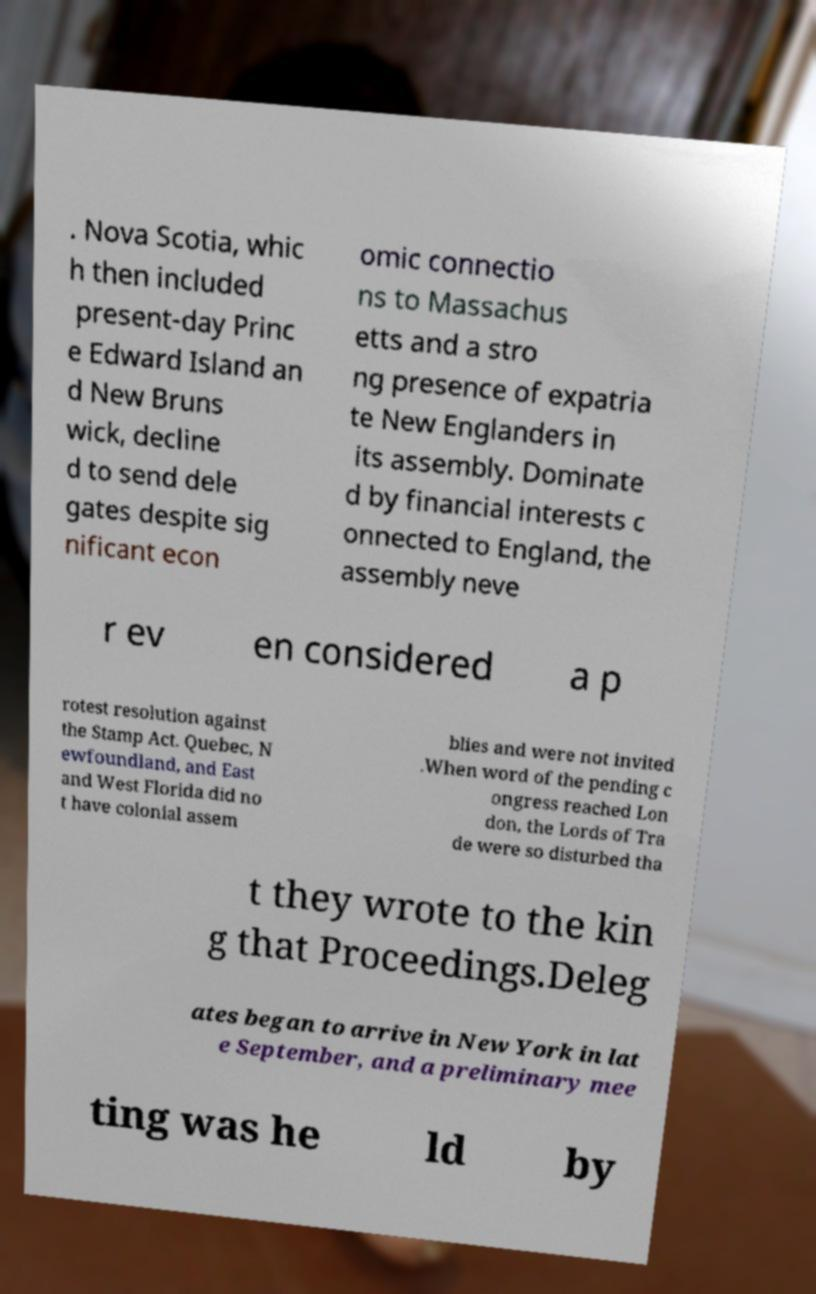Please identify and transcribe the text found in this image. . Nova Scotia, whic h then included present-day Princ e Edward Island an d New Bruns wick, decline d to send dele gates despite sig nificant econ omic connectio ns to Massachus etts and a stro ng presence of expatria te New Englanders in its assembly. Dominate d by financial interests c onnected to England, the assembly neve r ev en considered a p rotest resolution against the Stamp Act. Quebec, N ewfoundland, and East and West Florida did no t have colonial assem blies and were not invited .When word of the pending c ongress reached Lon don, the Lords of Tra de were so disturbed tha t they wrote to the kin g that Proceedings.Deleg ates began to arrive in New York in lat e September, and a preliminary mee ting was he ld by 